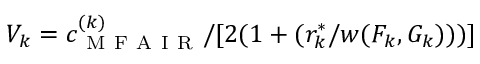Convert formula to latex. <formula><loc_0><loc_0><loc_500><loc_500>V _ { k } = c _ { M F A I R } ^ { ( k ) } / [ 2 ( 1 + ( r _ { k } ^ { \ast } / w ( F _ { k } , G _ { k } ) ) ) ]</formula> 